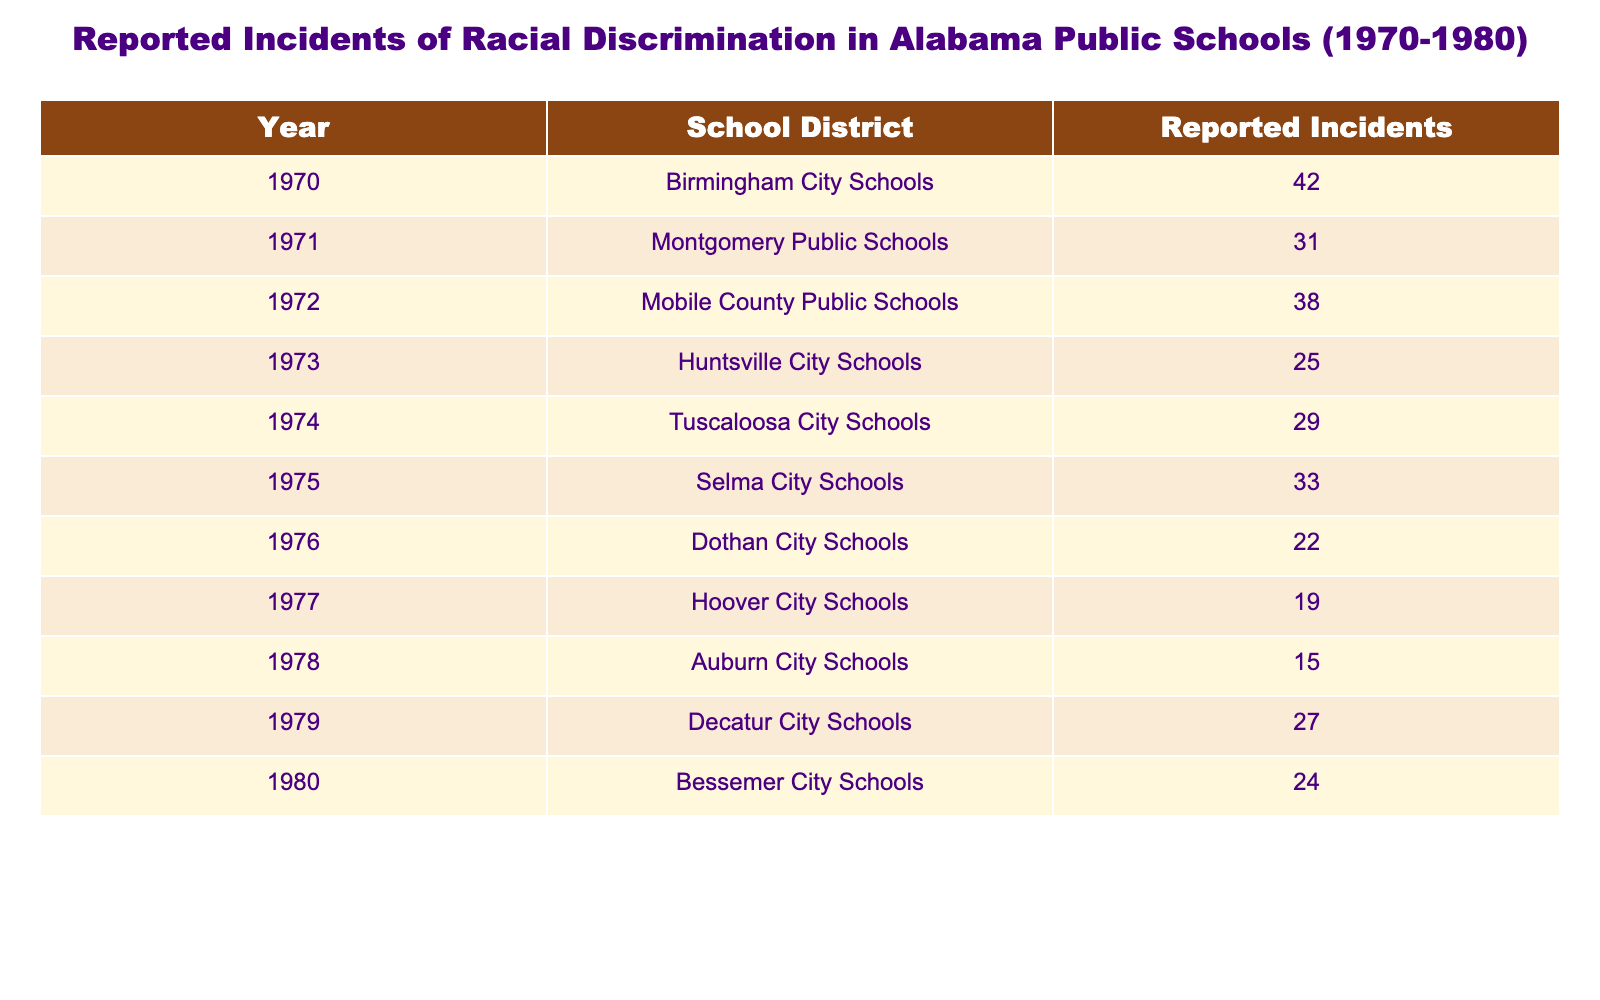What was the highest number of reported incidents of racial discrimination in a single year? By examining the table, the year with the highest reported incidents is 1970 with 42 incidents in Birmingham City Schools.
Answer: 42 Which school district reported the fewest incidents in the decade? Looking at the reported incidents, Auburn City Schools in 1978 reported the least with 15 incidents.
Answer: 15 What is the total number of reported incidents from 1970 to 1980? Adding all the reported incidents together: 42 + 31 + 38 + 25 + 29 + 33 + 22 + 19 + 15 + 27 + 24 =  319.
Answer: 319 In which year did Huntsville City Schools have their incidents reported? The table shows that Huntsville City Schools reported incidents in 1973.
Answer: 1973 What was the average number of reported incidents per year for the decade? To find the average, sum the reported incidents (319) and divide by the number of years (11): 319 / 11 ≈ 29. Therefore, the average is about 29 incidences.
Answer: 29 Did any school district report more than 40 incidents in a single year? Yes, Birmingham City Schools reported 42 incidents in 1970, which is more than 40.
Answer: Yes What is the difference in reported incidents between the highest and lowest years? The highest year was 1970 with 42 incidents, and the lowest was 1978 with 15 incidents. The difference is 42 - 15 = 27.
Answer: 27 Which two consecutive years had an increase in reported incidents? In 1975 (33 incidents) and 1976 (22 incidents), the report decreased. However, from 1978 (15 incidents) to 1979 (27 incidents), there was an increase of 12.
Answer: 1978 to 1979 How many years had reports of incidents below the average? The average is approximately 29. The years below this number are 1976 (22), 1977 (19), and 1978 (15), giving a total of 3 years below average.
Answer: 3 Was there a year in which reported incidents increased compared to the previous year? Yes, in 1979, the reported incidents increased from 15 in 1978 to 27 in 1979, showing an increase.
Answer: Yes Which school district experienced a notable decrease over the decade? Hoover City Schools reported 19 incidents in 1977, significantly lower than other years like Birmingham City Schools (42 incidents).
Answer: Hoover City Schools 